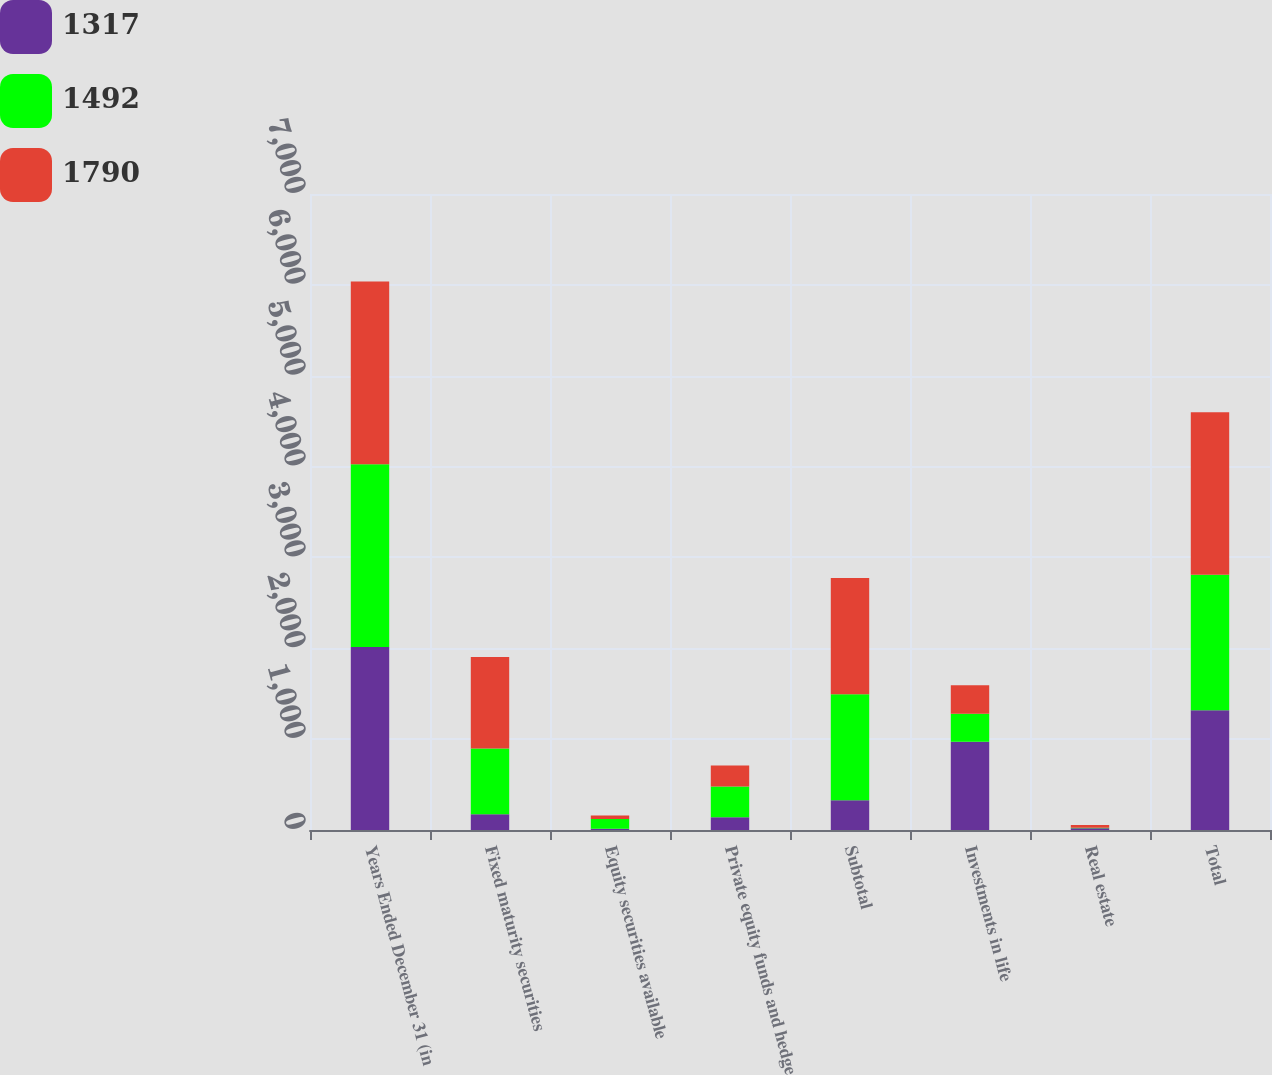Convert chart. <chart><loc_0><loc_0><loc_500><loc_500><stacked_bar_chart><ecel><fcel>Years Ended December 31 (in<fcel>Fixed maturity securities<fcel>Equity securities available<fcel>Private equity funds and hedge<fcel>Subtotal<fcel>Investments in life<fcel>Real estate<fcel>Total<nl><fcel>1317<fcel>2013<fcel>173<fcel>14<fcel>140<fcel>327<fcel>971<fcel>19<fcel>1317<nl><fcel>1492<fcel>2012<fcel>723<fcel>106<fcel>338<fcel>1167<fcel>309<fcel>7<fcel>1492<nl><fcel>1790<fcel>2011<fcel>1009<fcel>39<fcel>232<fcel>1280<fcel>312<fcel>30<fcel>1790<nl></chart> 